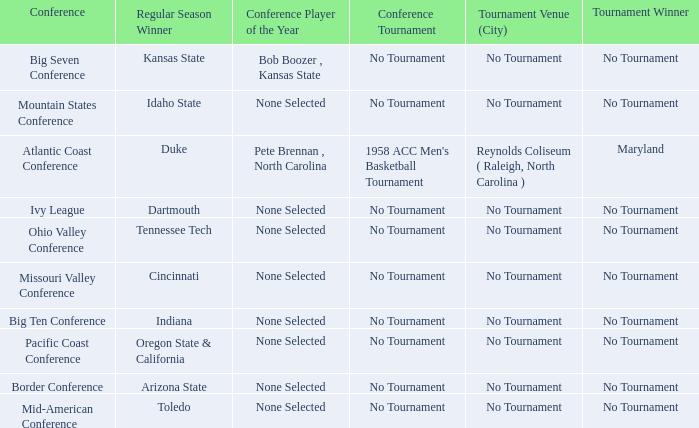Who won the tournament when Idaho State won the regular season? No Tournament. 